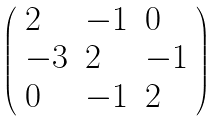Convert formula to latex. <formula><loc_0><loc_0><loc_500><loc_500>\left ( \begin{array} { l l l } { 2 } & { - 1 } & { 0 } \\ { - 3 } & { 2 } & { - 1 } \\ { 0 } & { - 1 } & { 2 } \end{array} \right )</formula> 